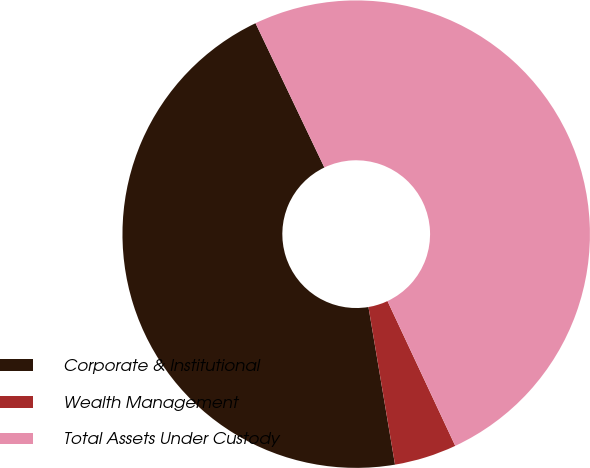Convert chart. <chart><loc_0><loc_0><loc_500><loc_500><pie_chart><fcel>Corporate & Institutional<fcel>Wealth Management<fcel>Total Assets Under Custody<nl><fcel>45.57%<fcel>4.31%<fcel>50.12%<nl></chart> 